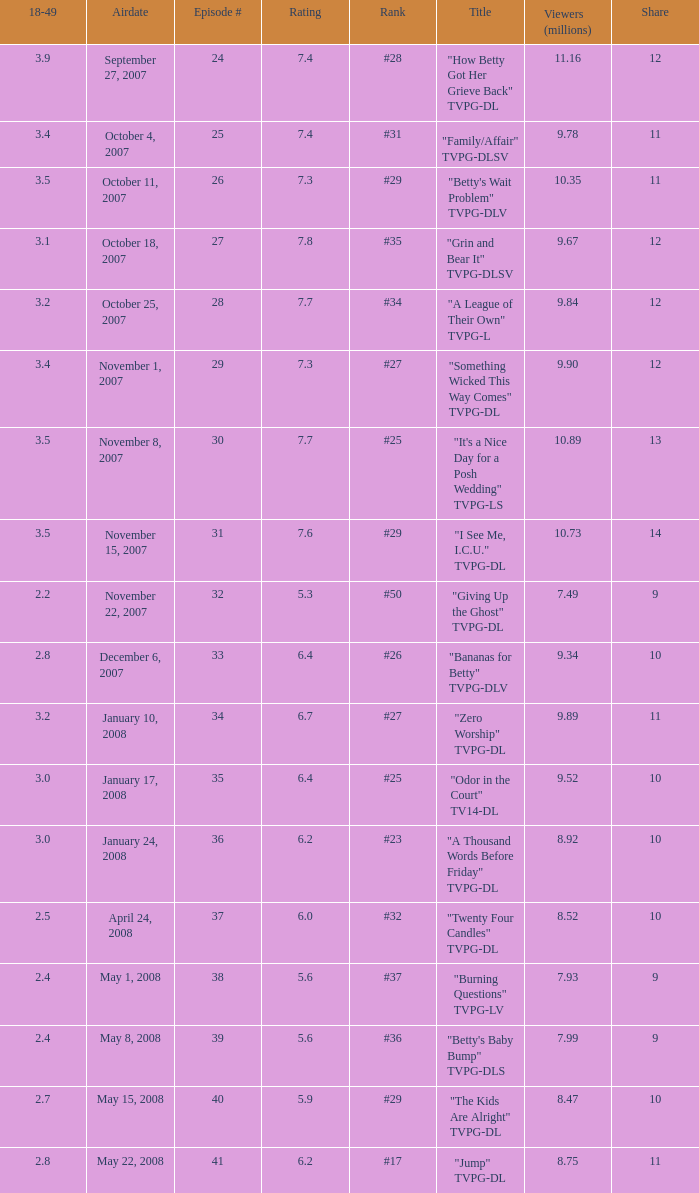Can you give me this table as a dict? {'header': ['18-49', 'Airdate', 'Episode #', 'Rating', 'Rank', 'Title', 'Viewers (millions)', 'Share'], 'rows': [['3.9', 'September 27, 2007', '24', '7.4', '#28', '"How Betty Got Her Grieve Back" TVPG-DL', '11.16', '12'], ['3.4', 'October 4, 2007', '25', '7.4', '#31', '"Family/Affair" TVPG-DLSV', '9.78', '11'], ['3.5', 'October 11, 2007', '26', '7.3', '#29', '"Betty\'s Wait Problem" TVPG-DLV', '10.35', '11'], ['3.1', 'October 18, 2007', '27', '7.8', '#35', '"Grin and Bear It" TVPG-DLSV', '9.67', '12'], ['3.2', 'October 25, 2007', '28', '7.7', '#34', '"A League of Their Own" TVPG-L', '9.84', '12'], ['3.4', 'November 1, 2007', '29', '7.3', '#27', '"Something Wicked This Way Comes" TVPG-DL', '9.90', '12'], ['3.5', 'November 8, 2007', '30', '7.7', '#25', '"It\'s a Nice Day for a Posh Wedding" TVPG-LS', '10.89', '13'], ['3.5', 'November 15, 2007', '31', '7.6', '#29', '"I See Me, I.C.U." TVPG-DL', '10.73', '14'], ['2.2', 'November 22, 2007', '32', '5.3', '#50', '"Giving Up the Ghost" TVPG-DL', '7.49', '9'], ['2.8', 'December 6, 2007', '33', '6.4', '#26', '"Bananas for Betty" TVPG-DLV', '9.34', '10'], ['3.2', 'January 10, 2008', '34', '6.7', '#27', '"Zero Worship" TVPG-DL', '9.89', '11'], ['3.0', 'January 17, 2008', '35', '6.4', '#25', '"Odor in the Court" TV14-DL', '9.52', '10'], ['3.0', 'January 24, 2008', '36', '6.2', '#23', '"A Thousand Words Before Friday" TVPG-DL', '8.92', '10'], ['2.5', 'April 24, 2008', '37', '6.0', '#32', '"Twenty Four Candles" TVPG-DL', '8.52', '10'], ['2.4', 'May 1, 2008', '38', '5.6', '#37', '"Burning Questions" TVPG-LV', '7.93', '9'], ['2.4', 'May 8, 2008', '39', '5.6', '#36', '"Betty\'s Baby Bump" TVPG-DLS', '7.99', '9'], ['2.7', 'May 15, 2008', '40', '5.9', '#29', '"The Kids Are Alright" TVPG-DL', '8.47', '10'], ['2.8', 'May 22, 2008', '41', '6.2', '#17', '"Jump" TVPG-DL', '8.75', '11']]} What is the Airdate of the episode that ranked #29 and had a share greater than 10? May 15, 2008. 